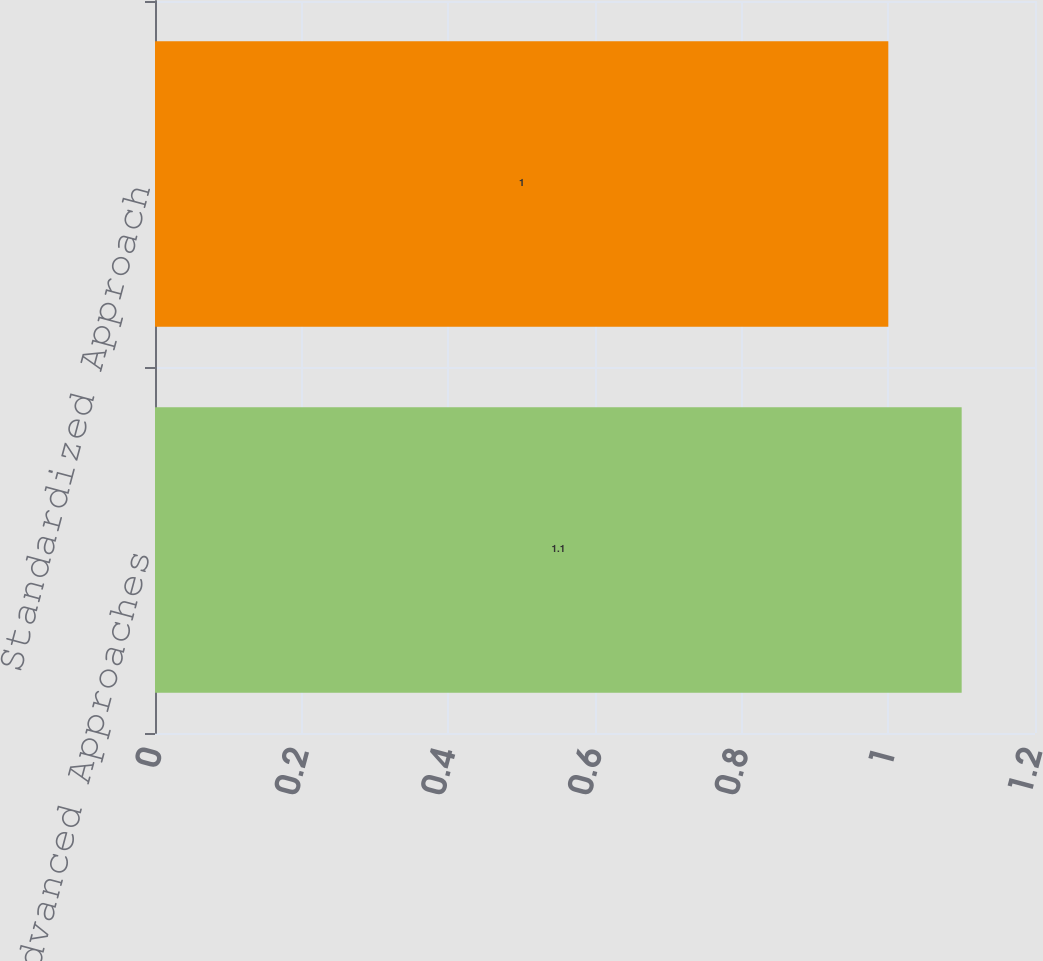Convert chart. <chart><loc_0><loc_0><loc_500><loc_500><bar_chart><fcel>Advanced Approaches<fcel>Standardized Approach<nl><fcel>1.1<fcel>1<nl></chart> 